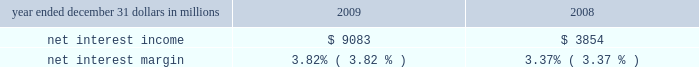Consolidated income statement review net income for 2009 was $ 2.4 billion and for 2008 was $ 914 million .
Amounts for 2009 include operating results of national city and the fourth quarter impact of a $ 687 million after-tax gain related to blackrock 2019s acquisition of bgi .
Increases in income statement comparisons to 2008 , except as noted , are primarily due to the operating results of national city .
Our consolidated income statement is presented in item 8 of this report .
Net interest income and net interest margin year ended december 31 dollars in millions 2009 2008 .
Changes in net interest income and margin result from the interaction of the volume and composition of interest-earning assets and related yields , interest-bearing liabilities and related rates paid , and noninterest-bearing sources of funding .
See statistical information 2013 analysis of year-to-year changes in net interest ( unaudited ) income and average consolidated balance sheet and net interest analysis in item 8 of this report for additional information .
Higher net interest income for 2009 compared with 2008 reflected the increase in average interest-earning assets due to national city and the improvement in the net interest margin .
The net interest margin was 3.82% ( 3.82 % ) for 2009 and 3.37% ( 3.37 % ) for 2008 .
The following factors impacted the comparison : 2022 a decrease in the rate accrued on interest-bearing liabilities of 97 basis points .
The rate accrued on interest-bearing deposits , the largest component , decreased 107 basis points .
2022 these factors were partially offset by a 45 basis point decrease in the yield on interest-earning assets .
The yield on loans , which represented the largest portion of our earning assets in 2009 , decreased 30 basis points .
2022 in addition , the impact of noninterest-bearing sources of funding decreased 7 basis points .
For comparing to the broader market , the average federal funds rate was .16% ( .16 % ) for 2009 compared with 1.94% ( 1.94 % ) for 2008 .
We expect our net interest income for 2010 will likely be modestly lower as a result of cash recoveries on purchased impaired loans in 2009 and additional run-off of higher- yielding assets , which could be mitigated by rising interest rates .
This assumes our current expectations for interest rates and economic conditions 2013 we include our current economic assumptions underlying our forward-looking statements in the cautionary statement regarding forward-looking information section of this item 7 .
Noninterest income summary noninterest income was $ 7.1 billion for 2009 and $ 2.4 billion for 2008 .
Noninterest income for 2009 included the following : 2022 the gain on blackrock/bgi transaction of $ 1.076 billion , 2022 net credit-related other-than-temporary impairments ( otti ) on debt and equity securities of $ 577 million , 2022 net gains on sales of securities of $ 550 million , 2022 gains on hedging of residential mortgage servicing rights of $ 355 million , 2022 valuation and sale income related to our commercial mortgage loans held for sale , net of hedges , of $ 107 million , 2022 gains of $ 103 million related to our blackrock ltip shares adjustment in the first quarter , and net losses on private equity and alternative investments of $ 93 million .
Noninterest income for 2008 included the following : 2022 net otti on debt and equity securities of $ 312 million , 2022 gains of $ 246 million related to our blackrock ltip shares adjustment , 2022 valuation and sale losses related to our commercial mortgage loans held for sale , net of hedges , of $ 197 million , 2022 impairment and other losses related to private equity and alternative investments of $ 180 million , 2022 income from hilliard lyons totaling $ 164 million , including the first quarter gain of $ 114 million from the sale of this business , 2022 net gains on sales of securities of $ 106 million , and 2022 a gain of $ 95 million related to the redemption of a portion of our visa class b common shares related to visa 2019s march 2008 initial public offering .
Additional analysis asset management revenue increased $ 172 million to $ 858 million in 2009 , compared with $ 686 million in 2008 .
This increase reflected improving equity markets , new business generation and a shift in assets into higher yielding equity investments during the second half of 2009 .
Assets managed totaled $ 103 billion at both december 31 , 2009 and 2008 , including the impact of national city .
The asset management group section of the business segments review section of this item 7 includes further discussion of assets under management .
Consumer services fees totaled $ 1.290 billion in 2009 compared with $ 623 million in 2008 .
Service charges on deposits totaled $ 950 million for 2009 and $ 372 million for 2008 .
Both increases were primarily driven by the impact of the national city acquisition .
Reduced consumer spending .
What was the average of noninterest income in 2008 and 2009 , in billions? 
Computations: ((7.1 + 2.4) / 2)
Answer: 4.75. 